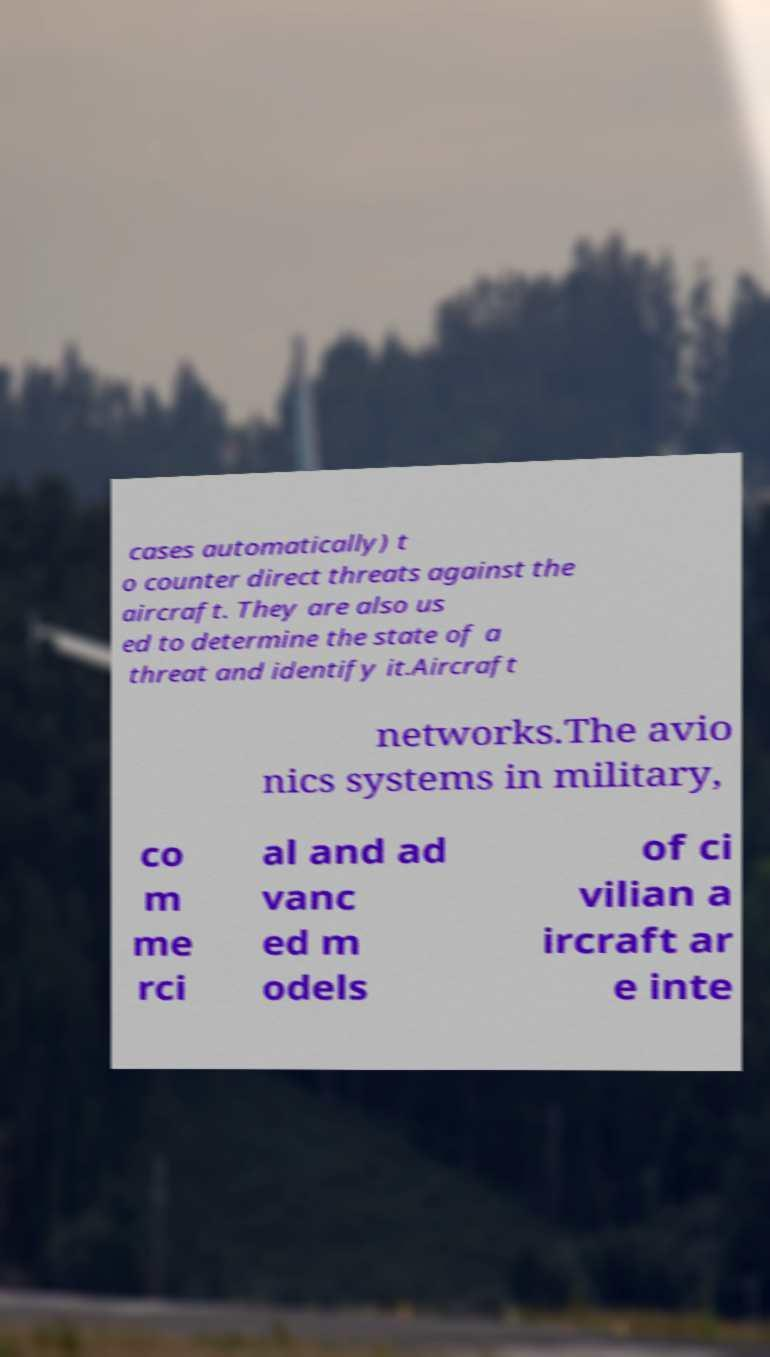Can you read and provide the text displayed in the image?This photo seems to have some interesting text. Can you extract and type it out for me? cases automatically) t o counter direct threats against the aircraft. They are also us ed to determine the state of a threat and identify it.Aircraft networks.The avio nics systems in military, co m me rci al and ad vanc ed m odels of ci vilian a ircraft ar e inte 